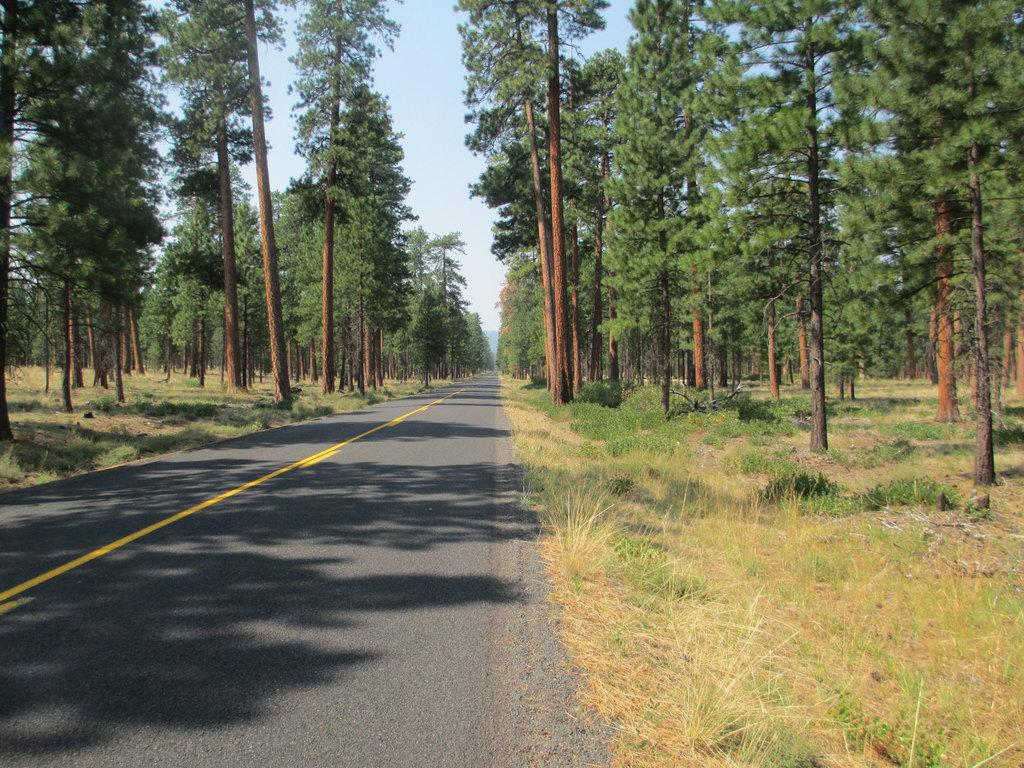What is the main feature of the image? There is a road in the image. What can be seen on the sides of the road? There are trees on the sides of the road. What type of vegetation is present on the ground? There are plants on the ground. What is visible in the background of the image? The sky is visible in the background of the image. Can you hear a whistle in the image? There is no mention of a whistle in the image, so it cannot be heard. 